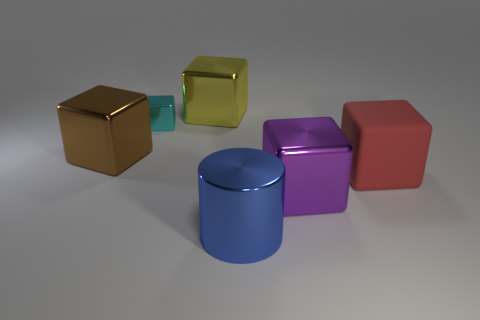How many other things are there of the same size as the red cube?
Your response must be concise. 4. What color is the large shiny thing in front of the big metal block that is on the right side of the large object behind the tiny metal block?
Keep it short and to the point. Blue. What is the shape of the object that is both left of the matte cube and on the right side of the large blue cylinder?
Make the answer very short. Cube. What number of other objects are there of the same shape as the large red object?
Your answer should be very brief. 4. What shape is the large metallic thing to the right of the large object that is in front of the large metallic cube that is in front of the red cube?
Give a very brief answer. Cube. How many things are either blue rubber blocks or large cylinders in front of the yellow cube?
Keep it short and to the point. 1. There is a large blue thing that is in front of the brown shiny object; is it the same shape as the big shiny thing on the left side of the large yellow metal object?
Your response must be concise. No. How many objects are either big yellow balls or big cylinders?
Your answer should be compact. 1. Is there any other thing that has the same material as the brown object?
Give a very brief answer. Yes. Are there any small cyan matte blocks?
Offer a terse response. No. 